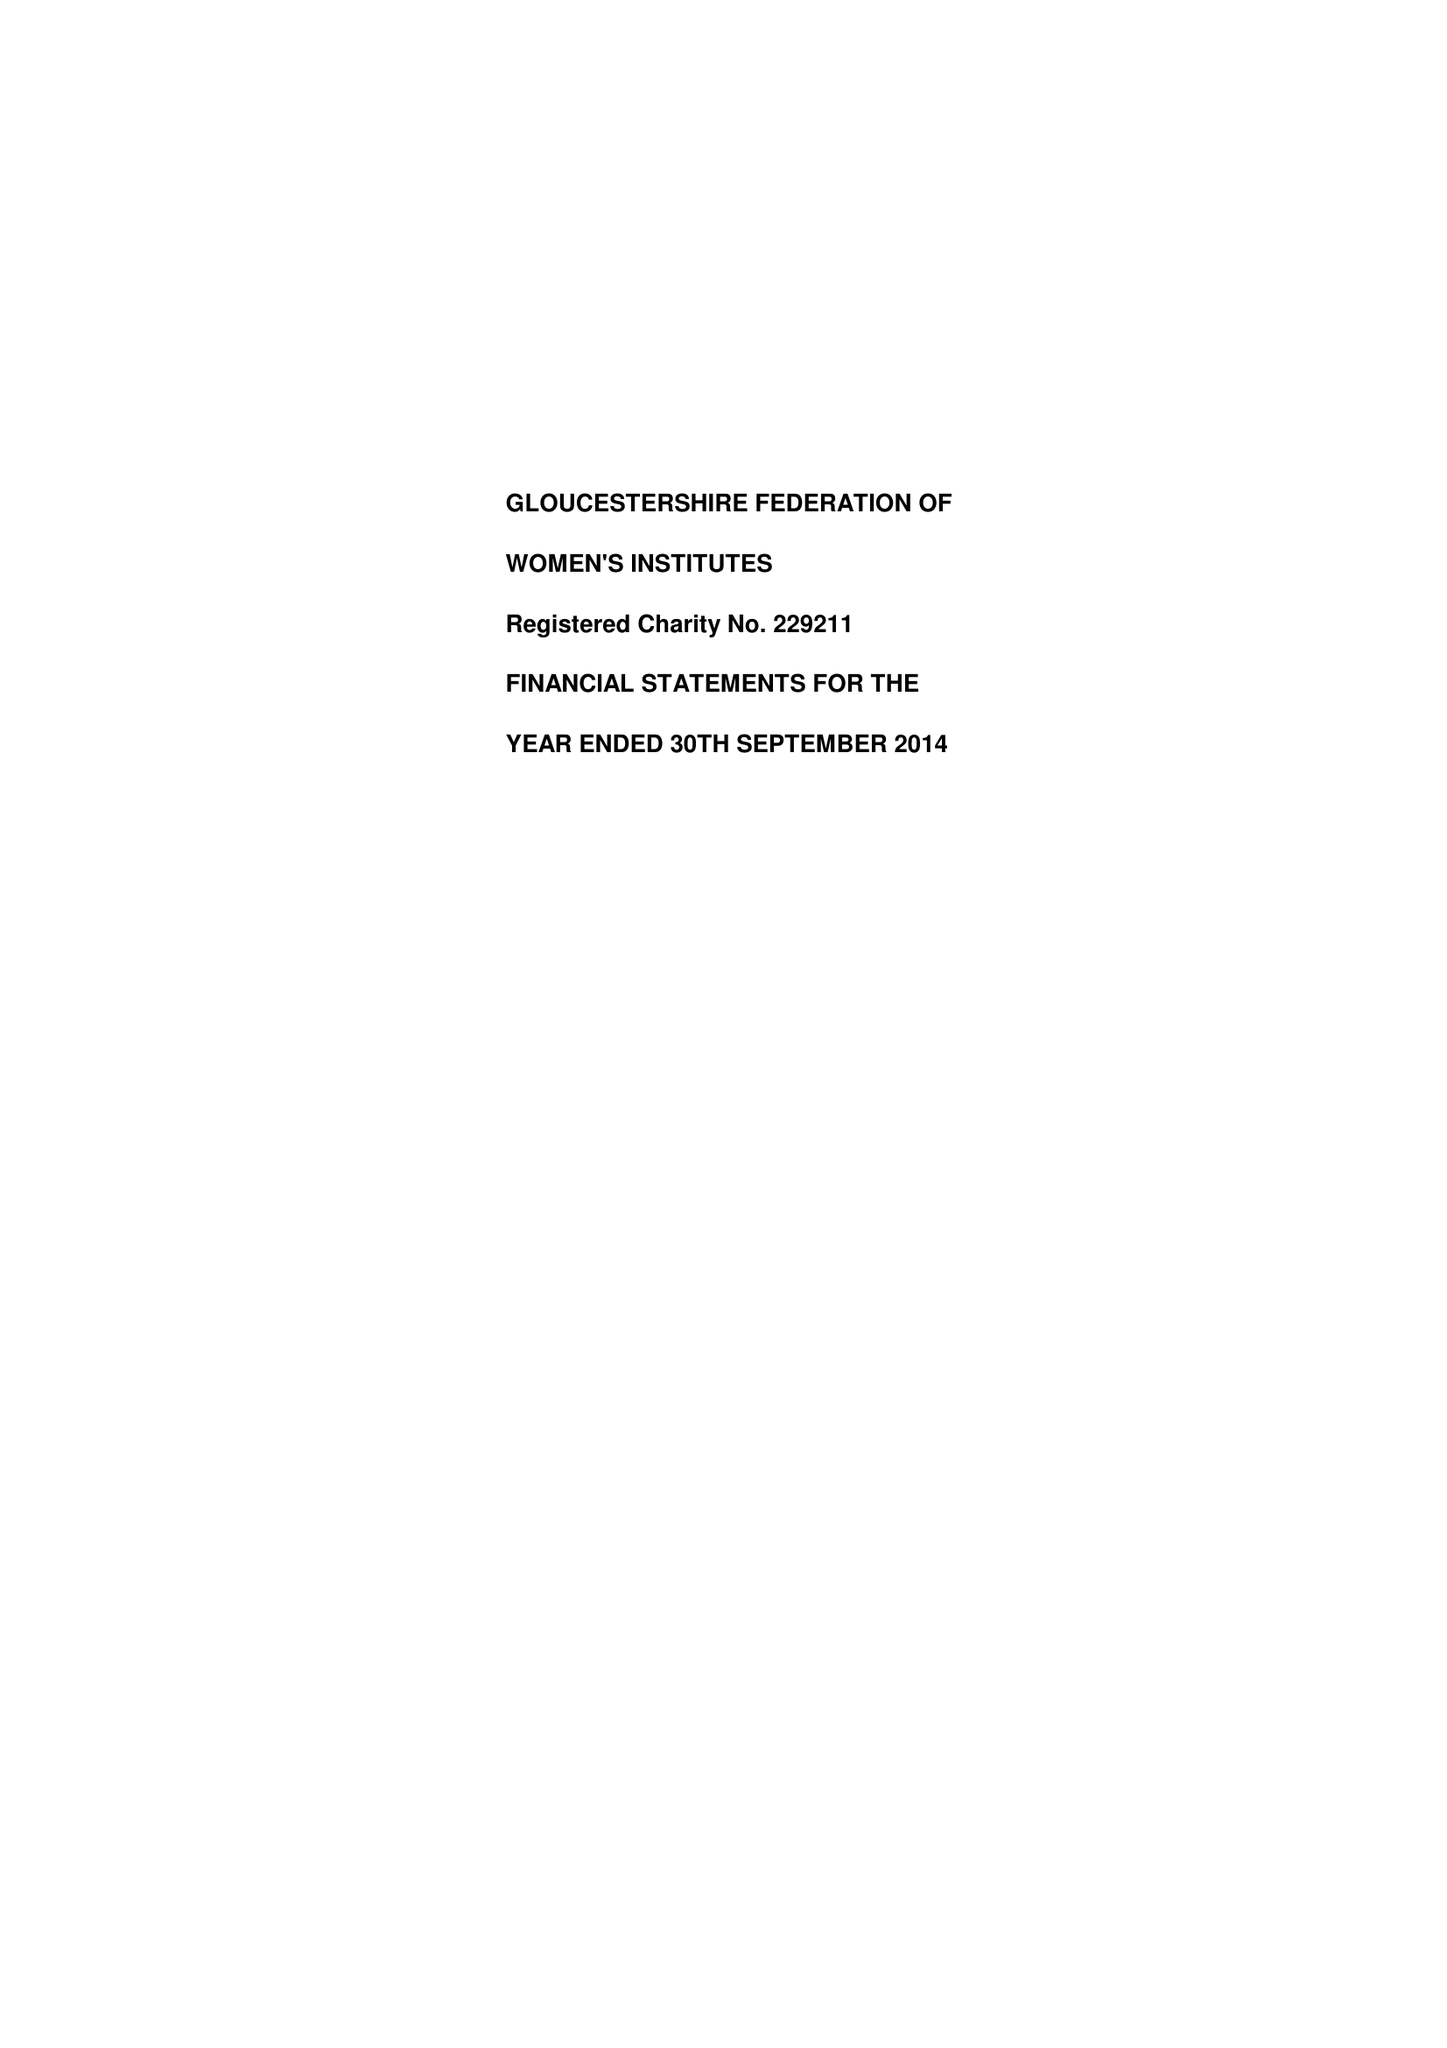What is the value for the income_annually_in_british_pounds?
Answer the question using a single word or phrase. 221123.00 